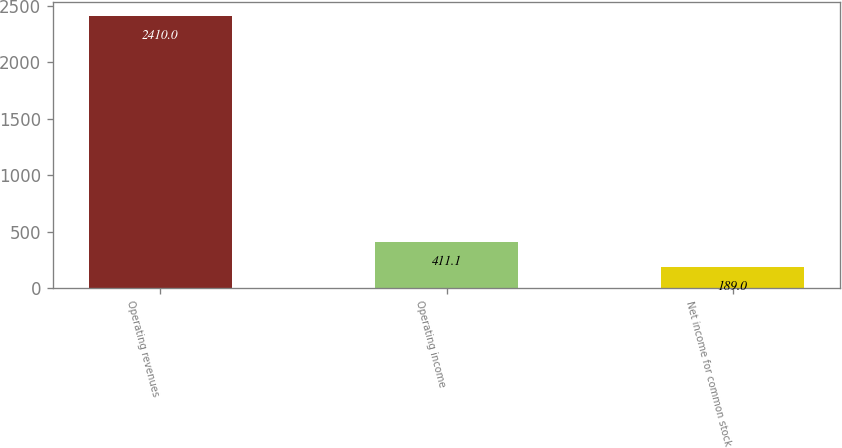Convert chart to OTSL. <chart><loc_0><loc_0><loc_500><loc_500><bar_chart><fcel>Operating revenues<fcel>Operating income<fcel>Net income for common stock<nl><fcel>2410<fcel>411.1<fcel>189<nl></chart> 